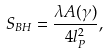Convert formula to latex. <formula><loc_0><loc_0><loc_500><loc_500>S _ { B H } = \frac { \lambda A ( \gamma ) } { 4 l _ { P } ^ { 2 } } ,</formula> 